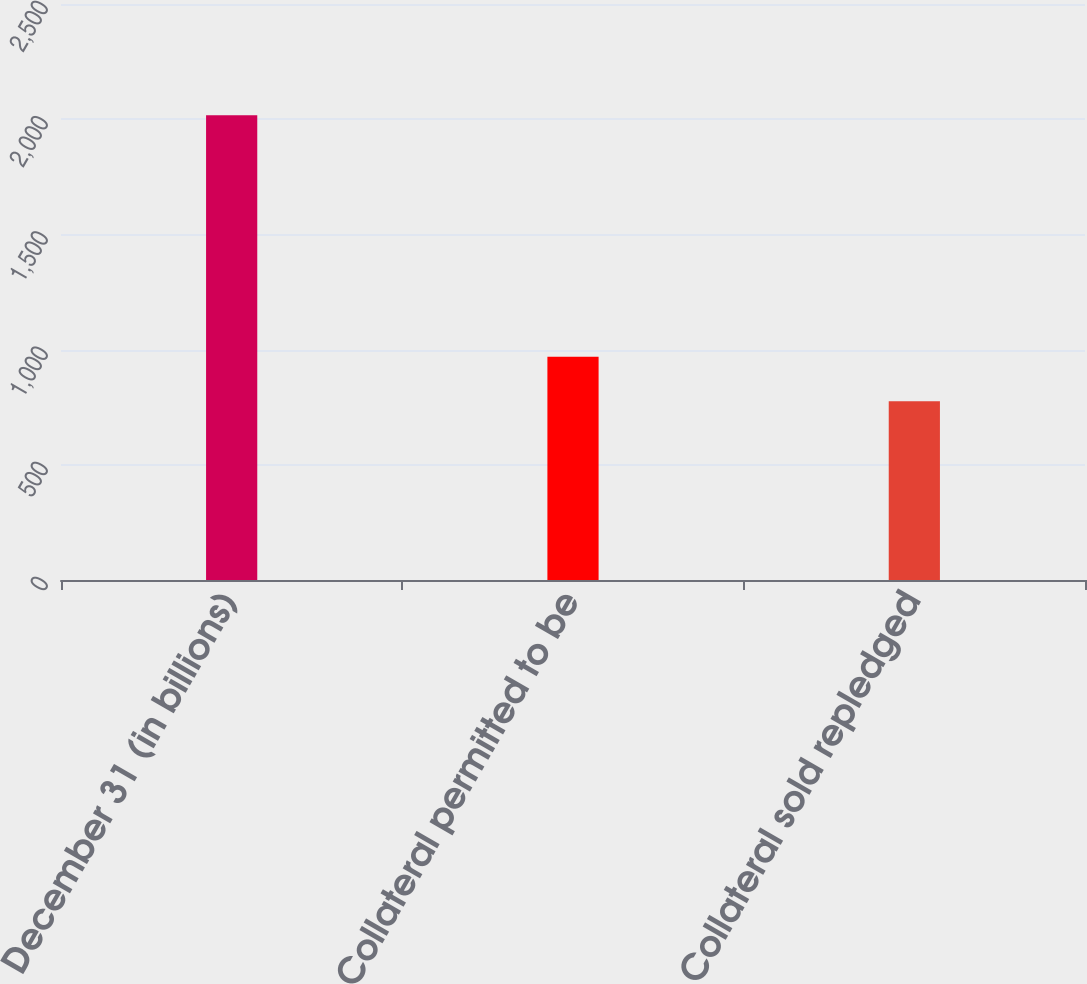Convert chart to OTSL. <chart><loc_0><loc_0><loc_500><loc_500><bar_chart><fcel>December 31 (in billions)<fcel>Collateral permitted to be<fcel>Collateral sold repledged<nl><fcel>2017<fcel>968.8<fcel>775.3<nl></chart> 